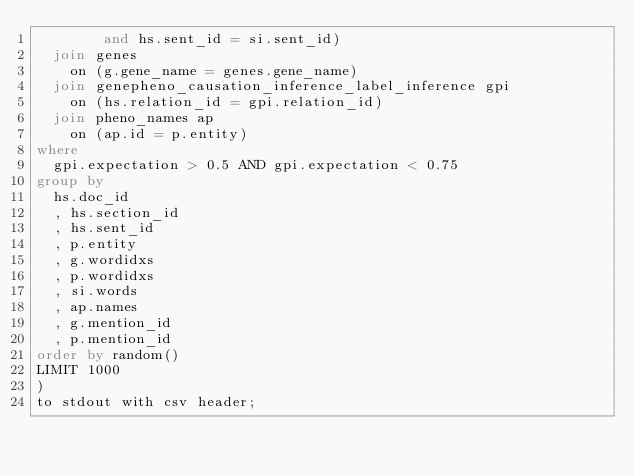<code> <loc_0><loc_0><loc_500><loc_500><_SQL_>        and hs.sent_id = si.sent_id)
  join genes
    on (g.gene_name = genes.gene_name)
  join genepheno_causation_inference_label_inference gpi
    on (hs.relation_id = gpi.relation_id)
  join pheno_names ap 
    on (ap.id = p.entity)
where
  gpi.expectation > 0.5 AND gpi.expectation < 0.75
group by
  hs.doc_id
  , hs.section_id
  , hs.sent_id
  , p.entity
  , g.wordidxs
  , p.wordidxs
  , si.words
  , ap.names
  , g.mention_id
  , p.mention_id
order by random()
LIMIT 1000
)
to stdout with csv header;
</code> 